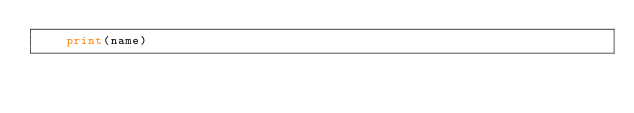Convert code to text. <code><loc_0><loc_0><loc_500><loc_500><_Python_>    print(name)</code> 